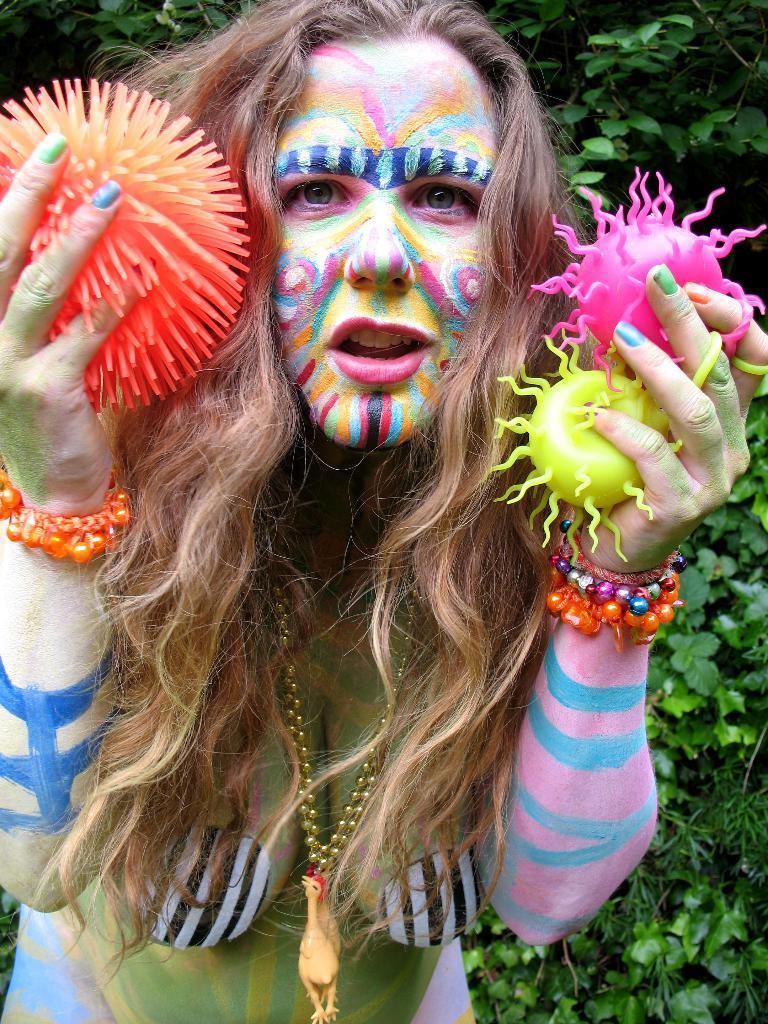Please provide a concise description of this image. In this picture we can see a woman with a painting on her and holding some objects with her hands and in the background we can see trees. 